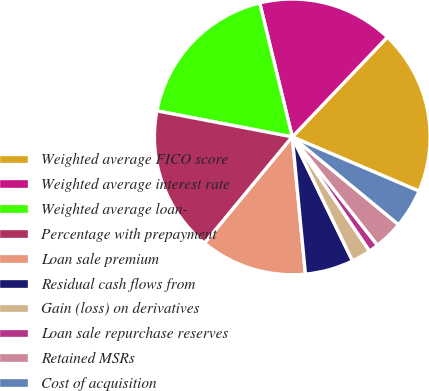Convert chart to OTSL. <chart><loc_0><loc_0><loc_500><loc_500><pie_chart><fcel>Weighted average FICO score<fcel>Weighted average interest rate<fcel>Weighted average loan-<fcel>Percentage with prepayment<fcel>Loan sale premium<fcel>Residual cash flows from<fcel>Gain (loss) on derivatives<fcel>Loan sale repurchase reserves<fcel>Retained MSRs<fcel>Cost of acquisition<nl><fcel>19.32%<fcel>15.91%<fcel>18.18%<fcel>17.05%<fcel>12.5%<fcel>5.68%<fcel>2.27%<fcel>1.14%<fcel>3.41%<fcel>4.55%<nl></chart> 